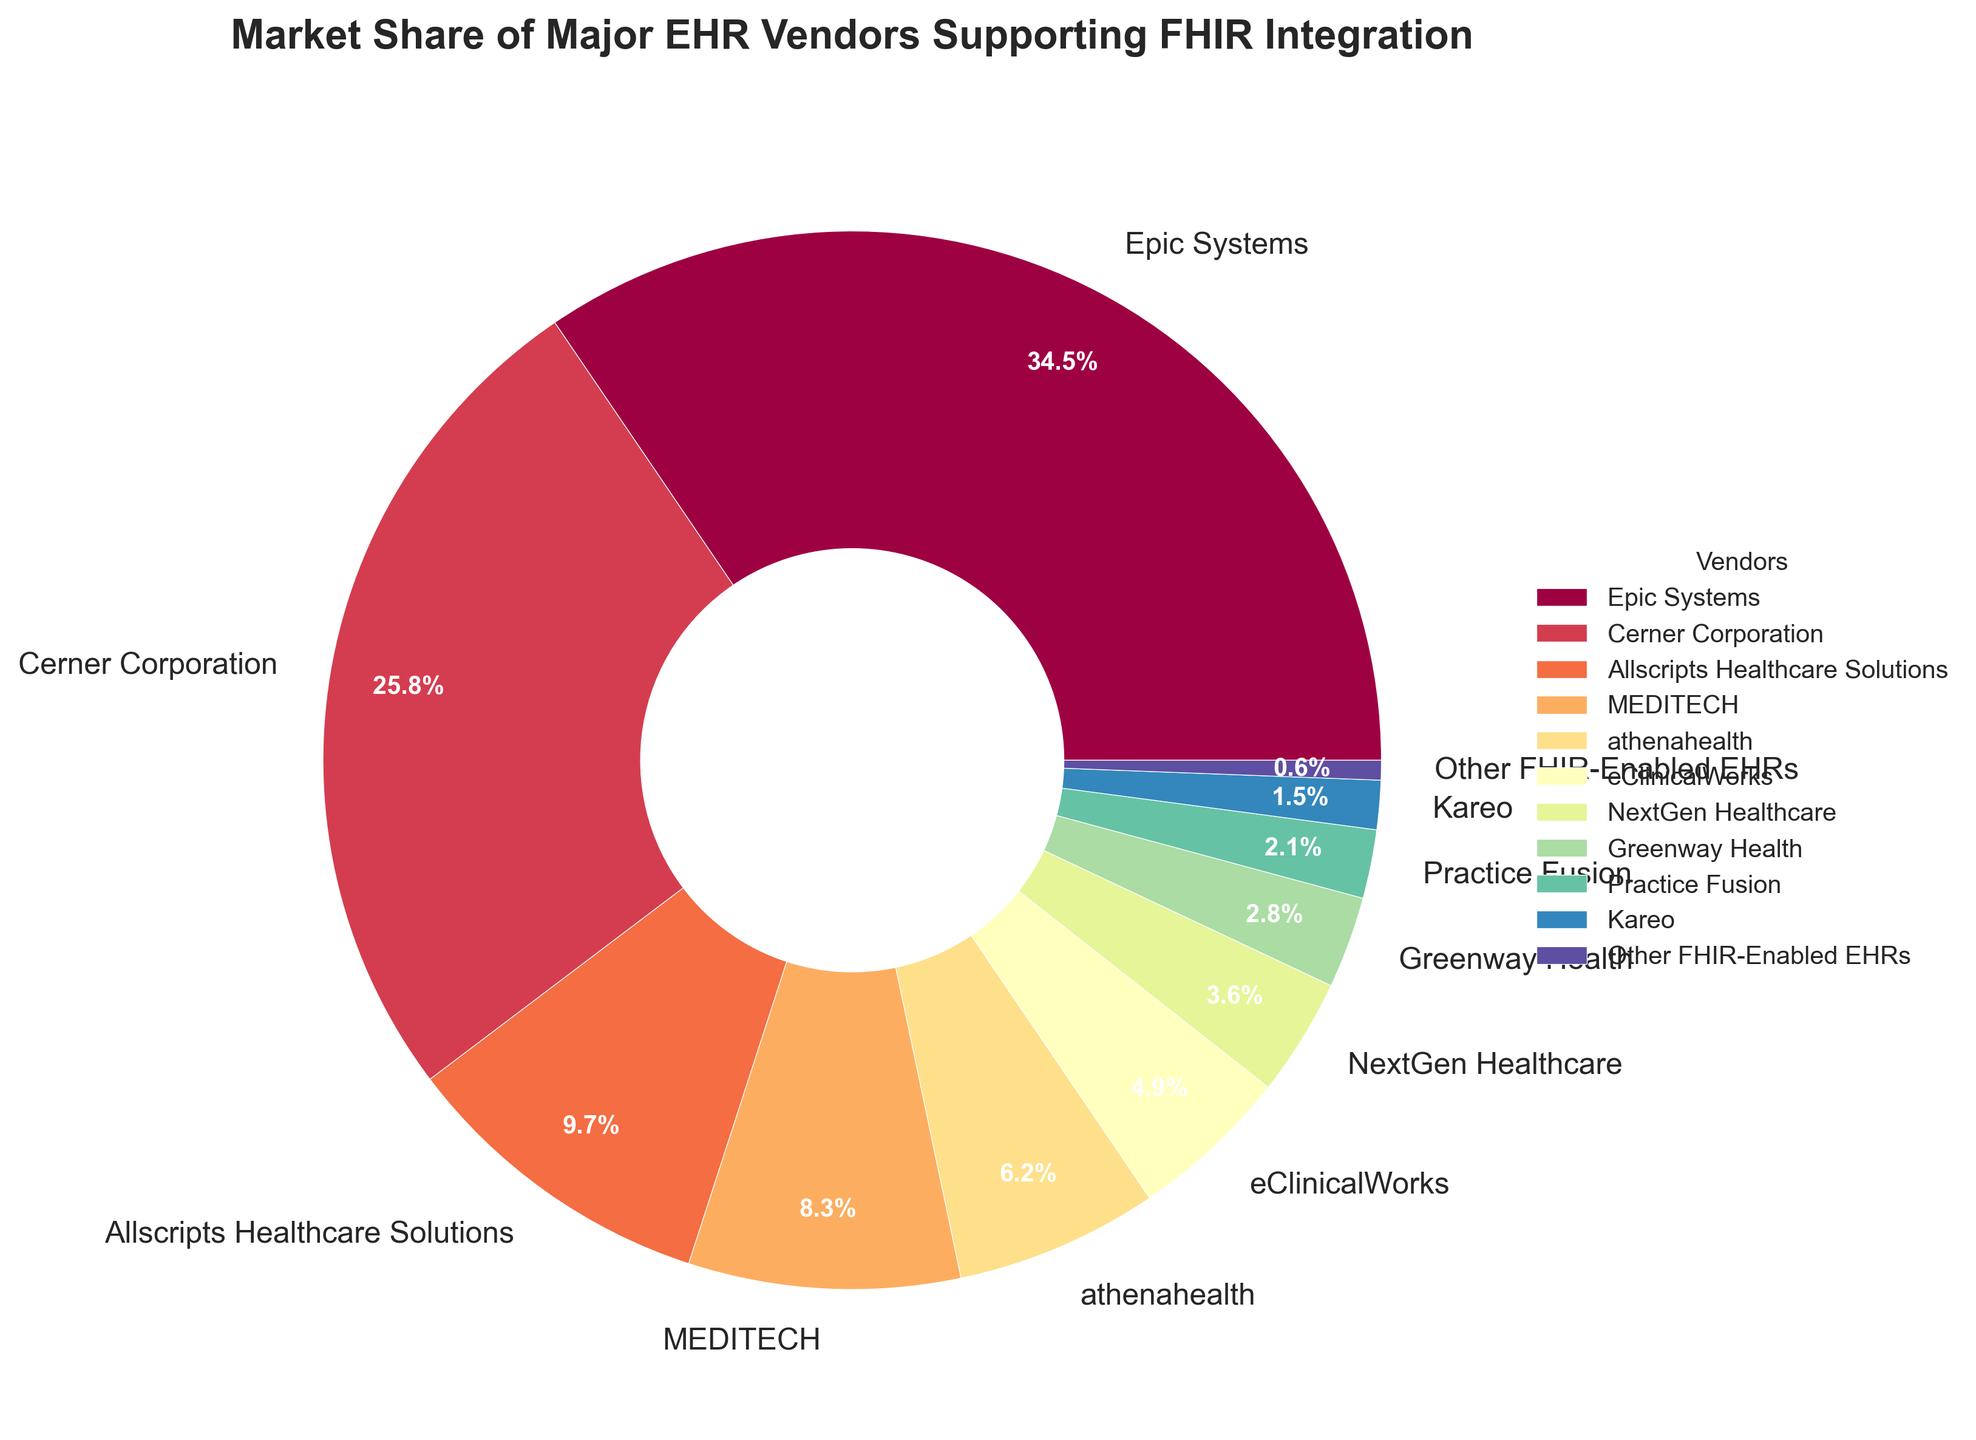Which vendor holds the largest market share in FHIR integration? The largest section in the pie chart corresponds to the vendor with the highest market share, which is labeled "Epic Systems".
Answer: Epic Systems What is the combined market share of Epic Systems and Cerner Corporation? Sum the percentages of Epic Systems (34.5%) and Cerner Corporation (25.8%): 34.5 + 25.8 = 60.3.
Answer: 60.3% Which vendor has the smallest visual segment in the pie chart? The smallest segment in the pie chart is labeled "Other FHIR-Enabled EHRs" and has a market share of 0.6%.
Answer: Other FHIR-Enabled EHRs How much larger is Epic Systems' market share compared to Practice Fusion's? Subtract Practice Fusion's market share (2.1%) from Epic Systems' market share (34.5%): 34.5 - 2.1 = 32.4.
Answer: 32.4% How many vendors have a market share above 10%? Identify the segments with values greater than 10%: Epic Systems (34.5%) and Cerner Corporation (25.8%). There are 2 vendors.
Answer: 2 Between athenahealth and eClinicalWorks, which vendor has a higher market share? Compare the market shares of athenahealth (6.2%) and eClinicalWorks (4.9%). Athenahealth has the higher market share.
Answer: athenahealth If the market shares of Allscripts Healthcare Solutions, MEDITECH, and Greenway Health were combined, what would their total market share be? Sum the market shares of Allscripts Healthcare Solutions (9.7%), MEDITECH (8.3%), and Greenway Health (2.8%): 9.7 + 8.3 + 2.8 = 20.8.
Answer: 20.8% What percentage of the market is held by vendors other than Epic Systems and Cerner Corporation? First, sum the market shares of Epic Systems (34.5%) and Cerner Corporation (25.8%): 34.5 + 25.8 = 60.3. Then, subtract this sum from 100%: 100 - 60.3 = 39.7.
Answer: 39.7% Which vendor has a market share close to MEDITECH's share? Identify the market share of MEDITECH (8.3%) and find the vendor with a comparable value. Allscripts Healthcare Solutions' market share is 9.7%, which is close to 8.3%.
Answer: Allscripts Healthcare Solutions 